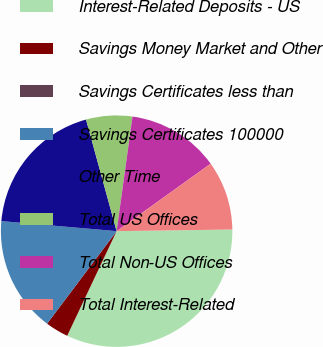Convert chart to OTSL. <chart><loc_0><loc_0><loc_500><loc_500><pie_chart><fcel>Interest-Related Deposits - US<fcel>Savings Money Market and Other<fcel>Savings Certificates less than<fcel>Savings Certificates 100000<fcel>Other Time<fcel>Total US Offices<fcel>Total Non-US Offices<fcel>Total Interest-Related<nl><fcel>32.25%<fcel>3.23%<fcel>0.0%<fcel>16.13%<fcel>19.35%<fcel>6.45%<fcel>12.9%<fcel>9.68%<nl></chart> 